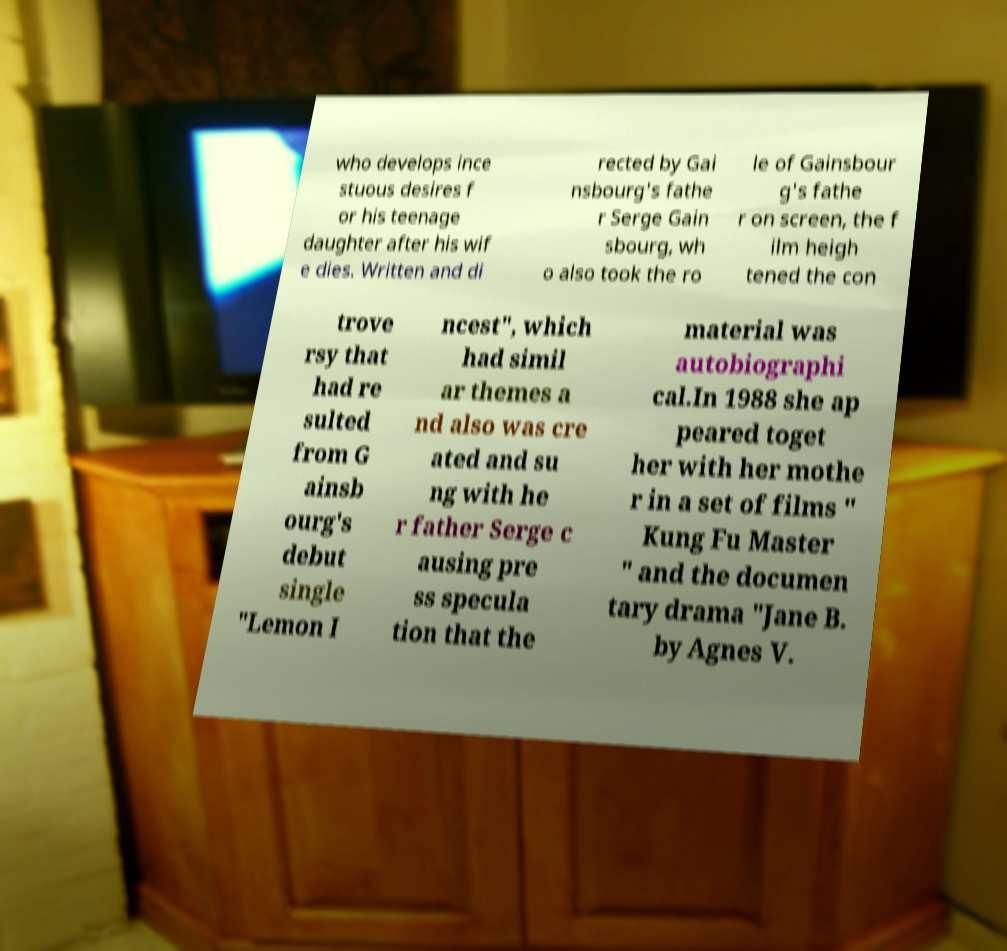What messages or text are displayed in this image? I need them in a readable, typed format. who develops ince stuous desires f or his teenage daughter after his wif e dies. Written and di rected by Gai nsbourg's fathe r Serge Gain sbourg, wh o also took the ro le of Gainsbour g's fathe r on screen, the f ilm heigh tened the con trove rsy that had re sulted from G ainsb ourg's debut single "Lemon I ncest", which had simil ar themes a nd also was cre ated and su ng with he r father Serge c ausing pre ss specula tion that the material was autobiographi cal.In 1988 she ap peared toget her with her mothe r in a set of films " Kung Fu Master " and the documen tary drama "Jane B. by Agnes V. 